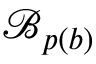<formula> <loc_0><loc_0><loc_500><loc_500>\mathcal { B } _ { p ( b ) }</formula> 